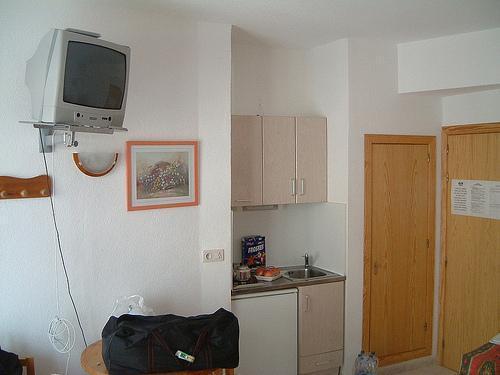How many televisions are there?
Give a very brief answer. 1. 